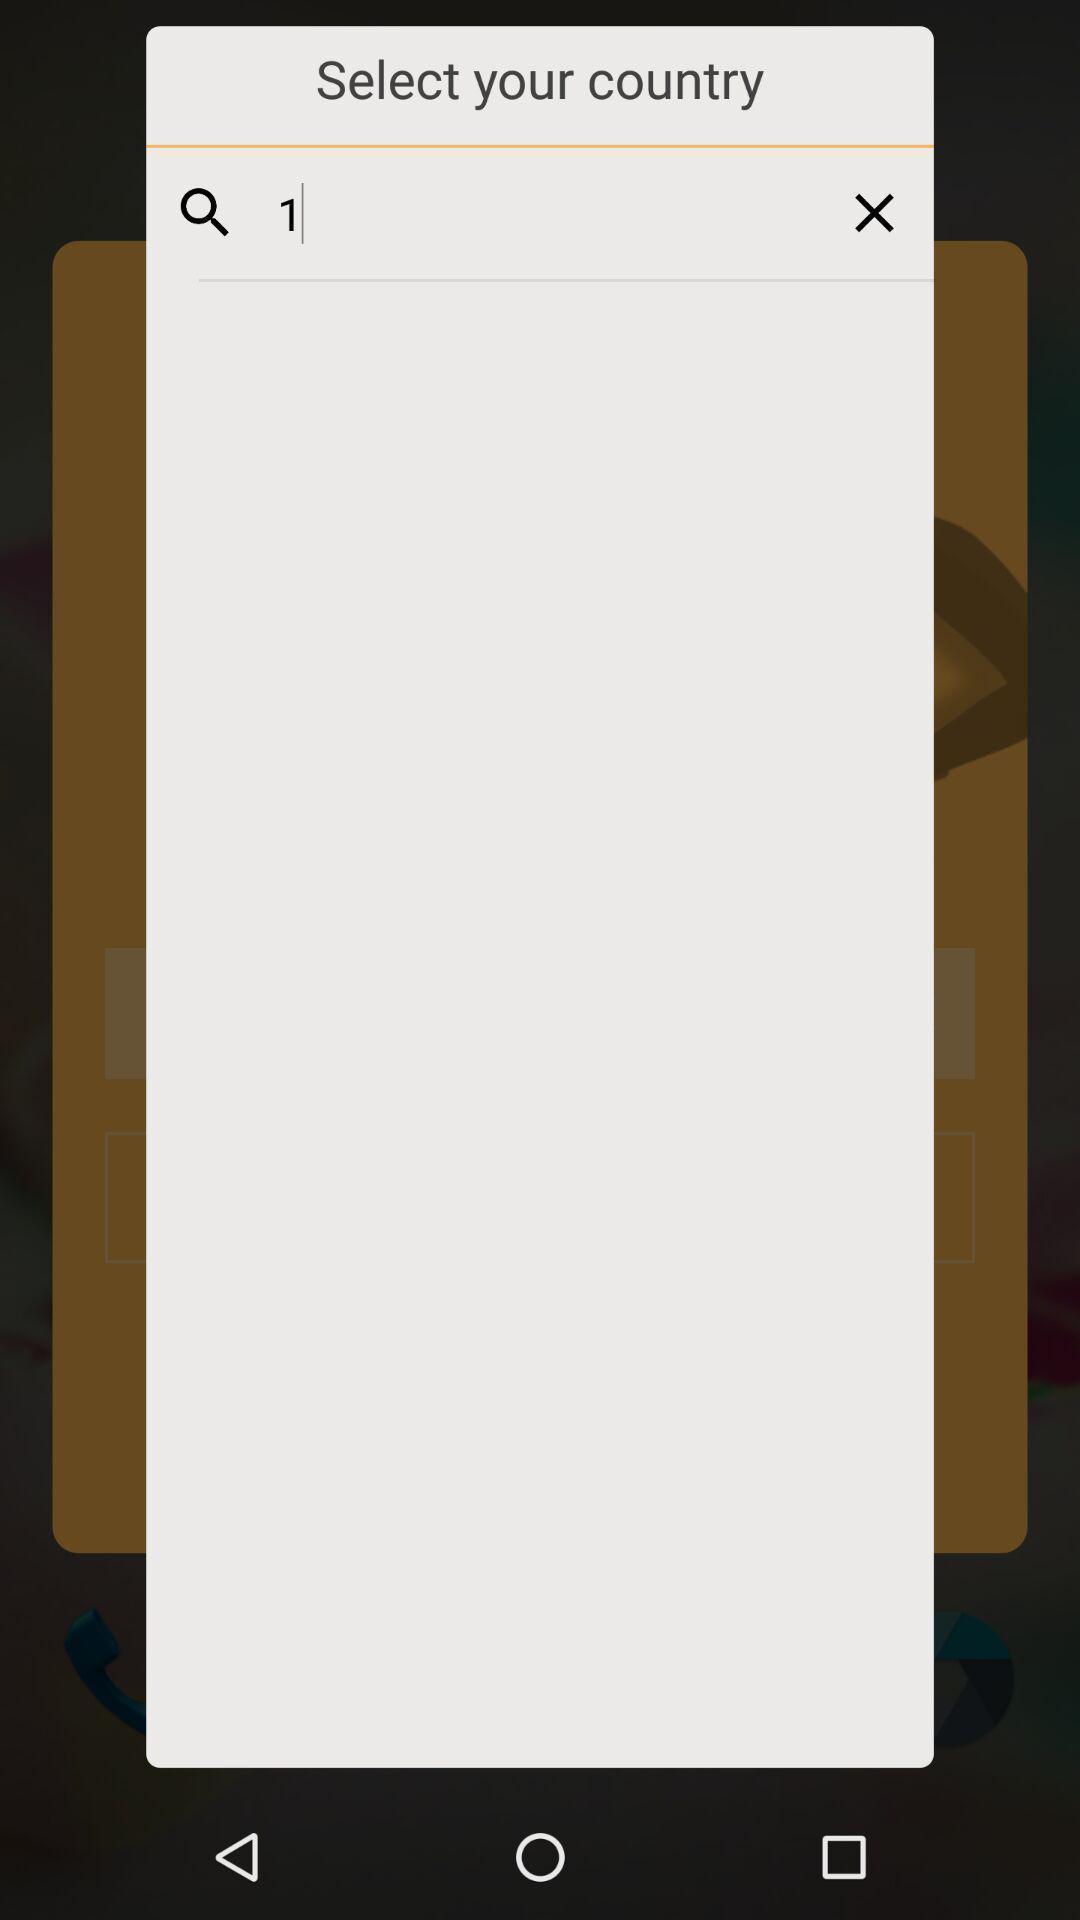Describe the content in this image. Search box of select country. 